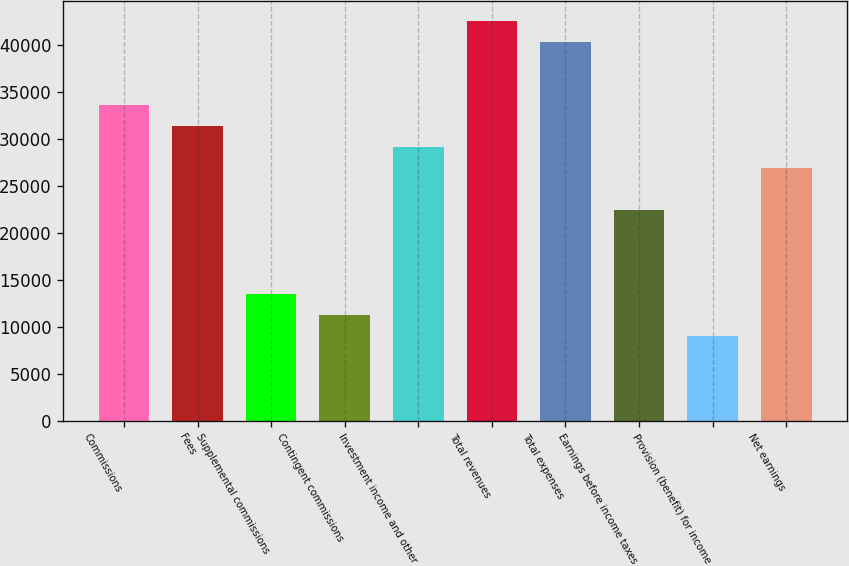<chart> <loc_0><loc_0><loc_500><loc_500><bar_chart><fcel>Commissions<fcel>Fees<fcel>Supplemental commissions<fcel>Contingent commissions<fcel>Investment income and other<fcel>Total revenues<fcel>Total expenses<fcel>Earnings before income taxes<fcel>Provision (benefit) for income<fcel>Net earnings<nl><fcel>33561.8<fcel>31324.5<fcel>13425.6<fcel>11188.2<fcel>29087.1<fcel>42511.3<fcel>40273.9<fcel>22375<fcel>8950.88<fcel>26849.8<nl></chart> 